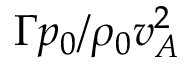Convert formula to latex. <formula><loc_0><loc_0><loc_500><loc_500>\Gamma p _ { 0 } / \rho _ { 0 } v _ { A } ^ { 2 }</formula> 